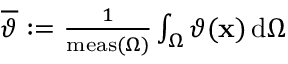<formula> <loc_0><loc_0><loc_500><loc_500>\begin{array} { r } { \overline { \vartheta } \colon = \frac { 1 } { m e a s ( \Omega ) } \int _ { \Omega } \vartheta ( x ) \, d \Omega } \end{array}</formula> 